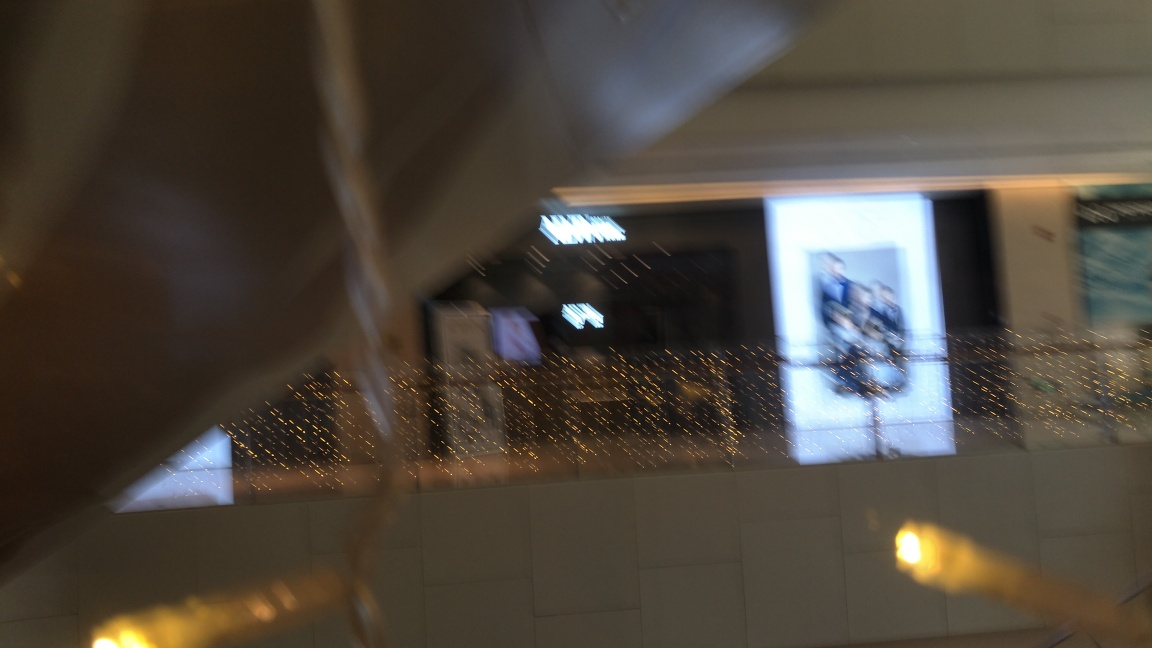Are the details of the building sharp? No, the details of the building are not sharp. The image appears blurry and out of focus, which prevents clear visibility of architectural details. 